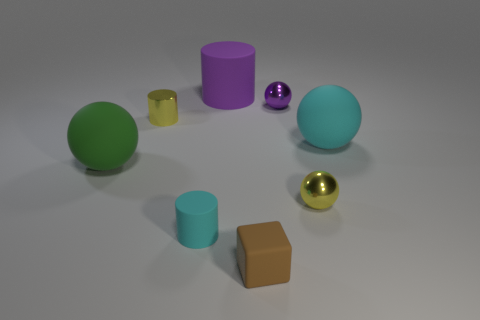Is there any other thing that is the same shape as the tiny brown matte object?
Keep it short and to the point. No. Does the tiny block have the same material as the small purple ball?
Make the answer very short. No. Are there any small spheres that have the same color as the large rubber cylinder?
Offer a very short reply. Yes. What is the color of the small matte thing that is to the right of the cyan cylinder?
Provide a short and direct response. Brown. There is a ball that is behind the big cyan sphere; is there a tiny thing on the right side of it?
Provide a succinct answer. Yes. Does the tiny rubber cylinder have the same color as the large matte object to the right of the brown block?
Provide a short and direct response. Yes. Are there any small yellow cylinders that have the same material as the small brown cube?
Keep it short and to the point. No. How many small matte blocks are there?
Offer a terse response. 1. The tiny yellow thing that is behind the cyan object that is on the right side of the large purple cylinder is made of what material?
Provide a short and direct response. Metal. The ball that is the same material as the green thing is what color?
Give a very brief answer. Cyan. 